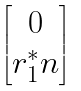<formula> <loc_0><loc_0><loc_500><loc_500>\begin{bmatrix} 0 \\ r _ { 1 } ^ { * } n \end{bmatrix}</formula> 